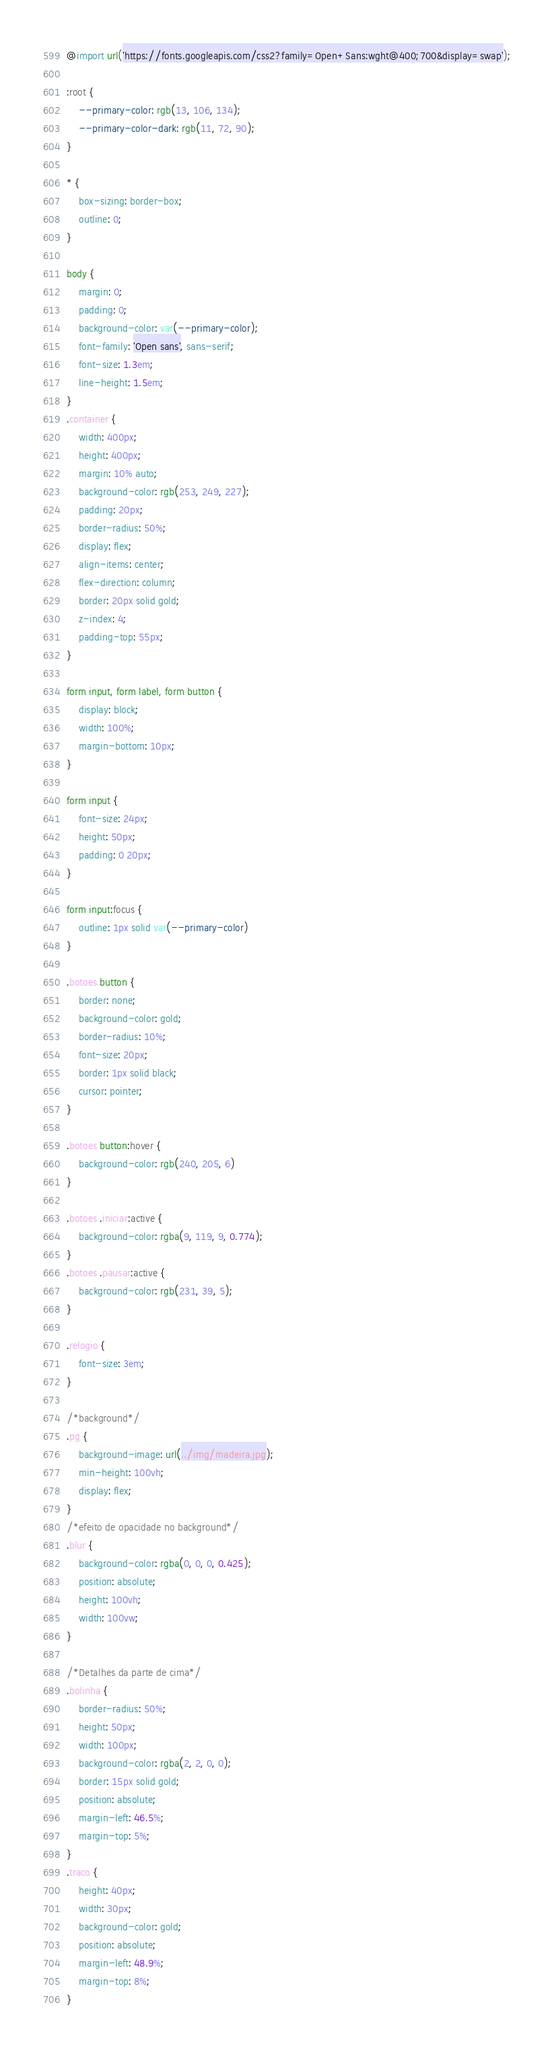Convert code to text. <code><loc_0><loc_0><loc_500><loc_500><_CSS_>@import url('https://fonts.googleapis.com/css2?family=Open+Sans:wght@400;700&display=swap');

:root {
    --primary-color: rgb(13, 106, 134);
    --primary-color-dark: rgb(11, 72, 90);
}

* {
    box-sizing: border-box;
    outline: 0;
}

body {
    margin: 0;
    padding: 0;
    background-color: var(--primary-color);
    font-family: 'Open sans', sans-serif;
    font-size: 1.3em;
    line-height: 1.5em;
}
.container {
    width: 400px;
    height: 400px;
    margin: 10% auto;
    background-color: rgb(253, 249, 227);
    padding: 20px;
    border-radius: 50%;
    display: flex;
    align-items: center;
    flex-direction: column;
    border: 20px solid gold;
    z-index: 4;
    padding-top: 55px;
}

form input, form label, form button {
    display: block;
    width: 100%;
    margin-bottom: 10px;
}

form input {
    font-size: 24px;
    height: 50px;
    padding: 0 20px;
}

form input:focus {
    outline: 1px solid var(--primary-color)
}

.botoes button {
    border: none;
    background-color: gold;
    border-radius: 10%;
    font-size: 20px;
    border: 1px solid black;
    cursor: pointer;
}

.botoes button:hover {
    background-color: rgb(240, 205, 6)
}

.botoes .iniciar:active {
    background-color: rgba(9, 119, 9, 0.774);
}
.botoes .pausar:active {
    background-color: rgb(231, 39, 5);
}

.relogio {
    font-size: 3em;
}

/*background*/
.pg { 
    background-image: url(../img/madeira.jpg);
    min-height: 100vh;
    display: flex;
}
/*efeito de opacidade no background*/
.blur {
    background-color: rgba(0, 0, 0, 0.425);
    position: absolute;
    height: 100vh;
    width: 100vw;
} 

/*Detalhes da parte de cima*/
.bolinha {
    border-radius: 50%;
    height: 50px;
    width: 100px;
    background-color: rgba(2, 2, 0, 0);
    border: 15px solid gold;
    position: absolute;
    margin-left: 46.5%;
    margin-top: 5%;
}
.traco {
    height: 40px;
    width: 30px;
    background-color: gold;
    position: absolute;
    margin-left: 48.9%;
    margin-top: 8%;
}</code> 